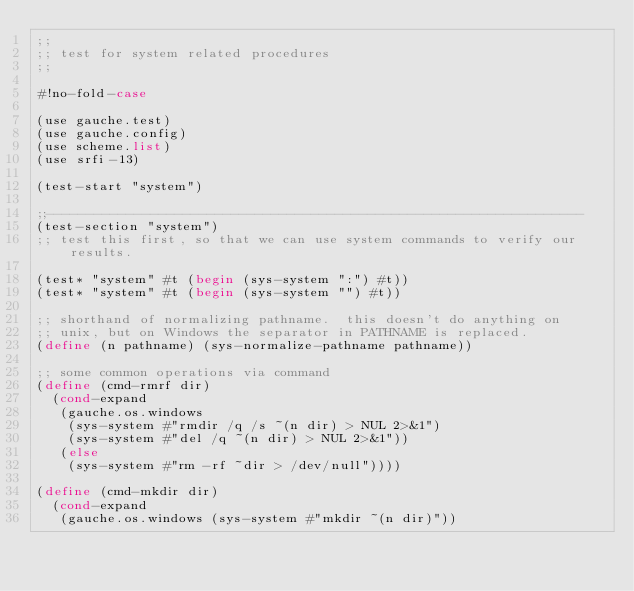<code> <loc_0><loc_0><loc_500><loc_500><_Scheme_>;;
;; test for system related procedures
;;

#!no-fold-case

(use gauche.test)
(use gauche.config)
(use scheme.list)
(use srfi-13)

(test-start "system")

;;-------------------------------------------------------------------
(test-section "system")
;; test this first, so that we can use system commands to verify our results.

(test* "system" #t (begin (sys-system ":") #t))
(test* "system" #t (begin (sys-system "") #t))

;; shorthand of normalizing pathname.  this doesn't do anything on
;; unix, but on Windows the separator in PATHNAME is replaced.
(define (n pathname) (sys-normalize-pathname pathname))

;; some common operations via command
(define (cmd-rmrf dir)
  (cond-expand
   (gauche.os.windows
    (sys-system #"rmdir /q /s ~(n dir) > NUL 2>&1")
    (sys-system #"del /q ~(n dir) > NUL 2>&1"))
   (else
    (sys-system #"rm -rf ~dir > /dev/null"))))

(define (cmd-mkdir dir)
  (cond-expand
   (gauche.os.windows (sys-system #"mkdir ~(n dir)"))</code> 